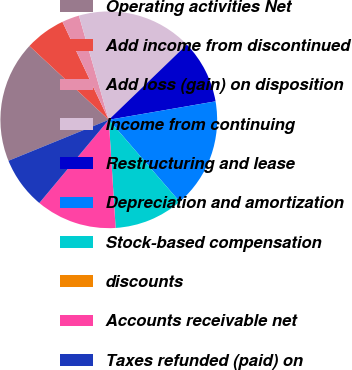Convert chart to OTSL. <chart><loc_0><loc_0><loc_500><loc_500><pie_chart><fcel>Operating activities Net<fcel>Add income from discontinued<fcel>Add loss (gain) on disposition<fcel>Income from continuing<fcel>Restructuring and lease<fcel>Depreciation and amortization<fcel>Stock-based compensation<fcel>discounts<fcel>Accounts receivable net<fcel>Taxes refunded (paid) on<nl><fcel>18.1%<fcel>6.04%<fcel>2.59%<fcel>17.24%<fcel>9.48%<fcel>16.37%<fcel>10.34%<fcel>0.01%<fcel>12.07%<fcel>7.76%<nl></chart> 